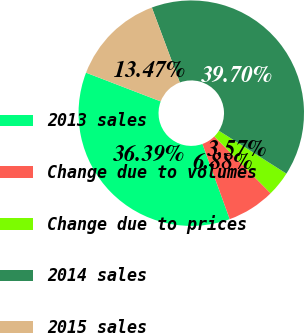Convert chart. <chart><loc_0><loc_0><loc_500><loc_500><pie_chart><fcel>2013 sales<fcel>Change due to volumes<fcel>Change due to prices<fcel>2014 sales<fcel>2015 sales<nl><fcel>36.39%<fcel>6.88%<fcel>3.57%<fcel>39.7%<fcel>13.47%<nl></chart> 